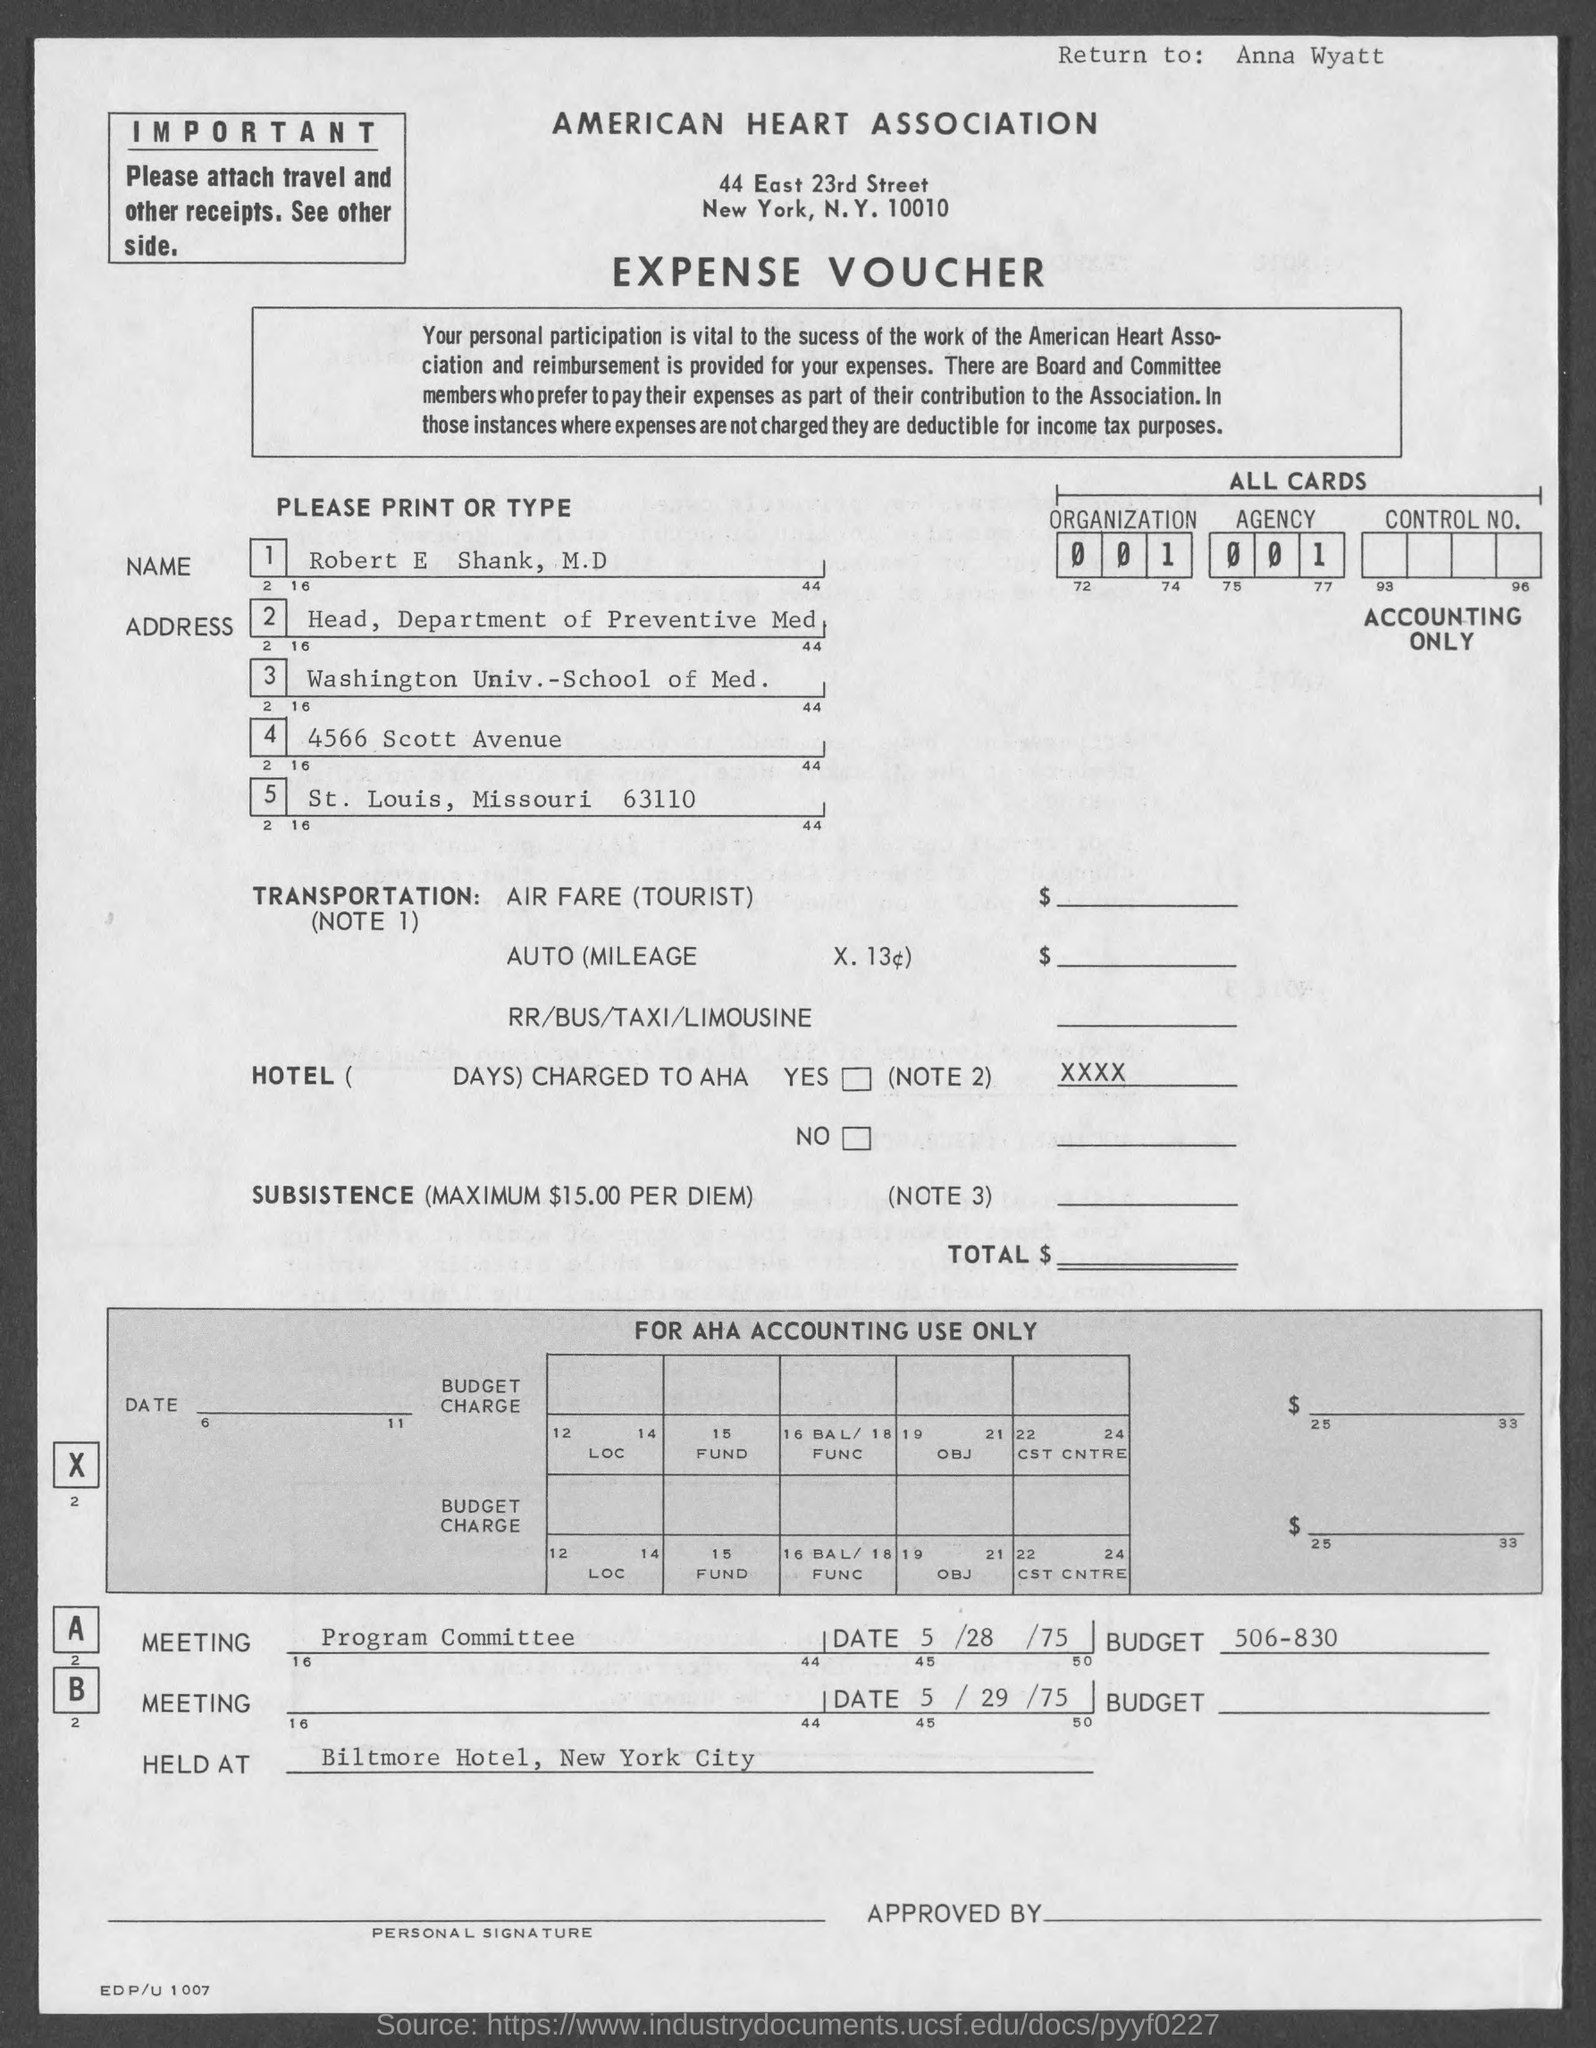In which city is american heart association located ?
Keep it short and to the point. New york. In which state is washington univ.- school of med. at?
Offer a very short reply. Missouri. 